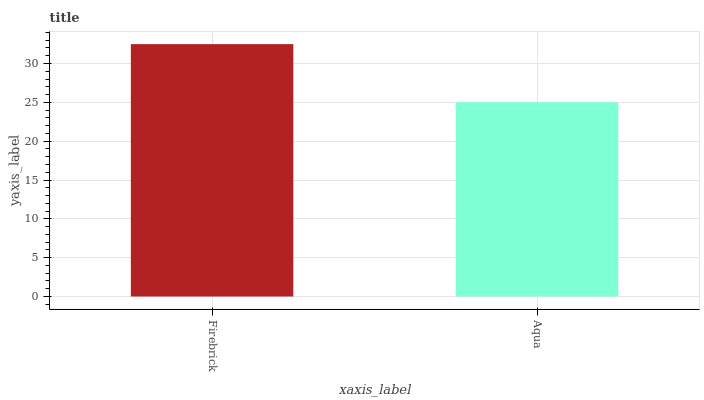Is Aqua the minimum?
Answer yes or no. Yes. Is Firebrick the maximum?
Answer yes or no. Yes. Is Aqua the maximum?
Answer yes or no. No. Is Firebrick greater than Aqua?
Answer yes or no. Yes. Is Aqua less than Firebrick?
Answer yes or no. Yes. Is Aqua greater than Firebrick?
Answer yes or no. No. Is Firebrick less than Aqua?
Answer yes or no. No. Is Firebrick the high median?
Answer yes or no. Yes. Is Aqua the low median?
Answer yes or no. Yes. Is Aqua the high median?
Answer yes or no. No. Is Firebrick the low median?
Answer yes or no. No. 